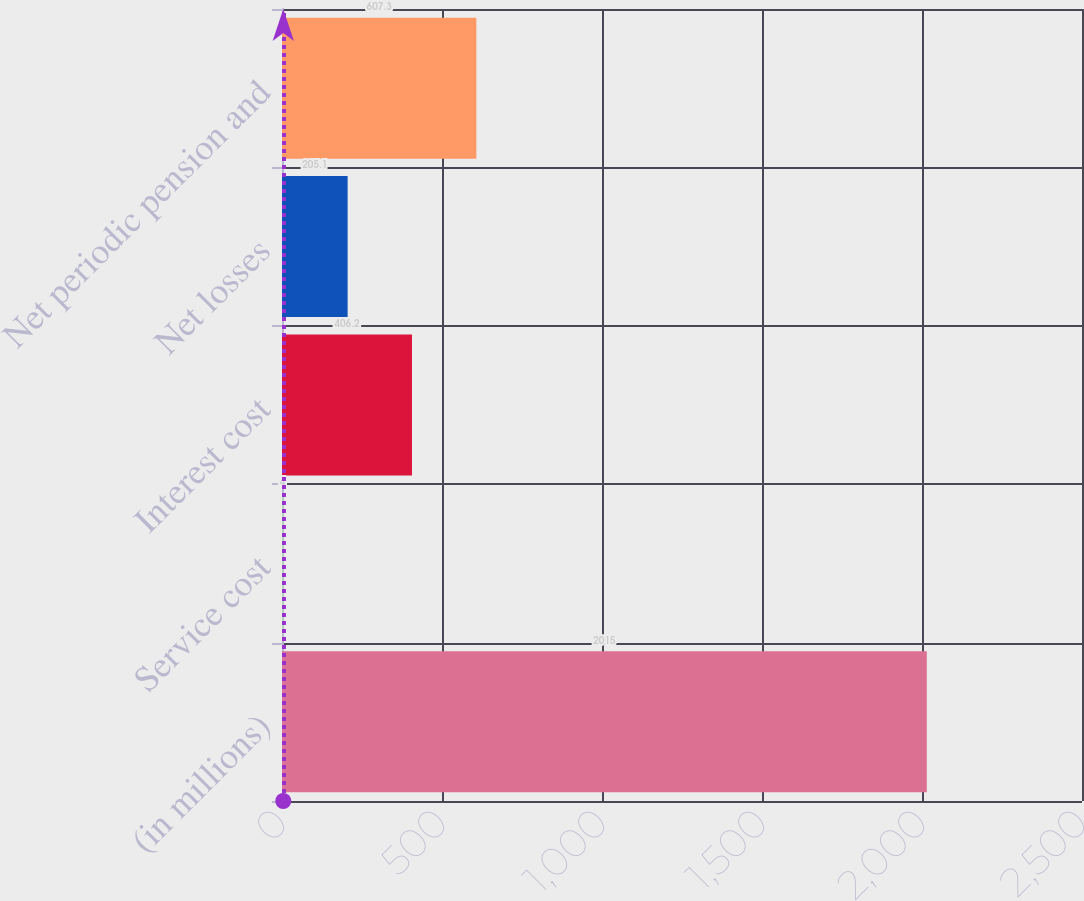Convert chart. <chart><loc_0><loc_0><loc_500><loc_500><bar_chart><fcel>(in millions)<fcel>Service cost<fcel>Interest cost<fcel>Net losses<fcel>Net periodic pension and<nl><fcel>2015<fcel>4<fcel>406.2<fcel>205.1<fcel>607.3<nl></chart> 